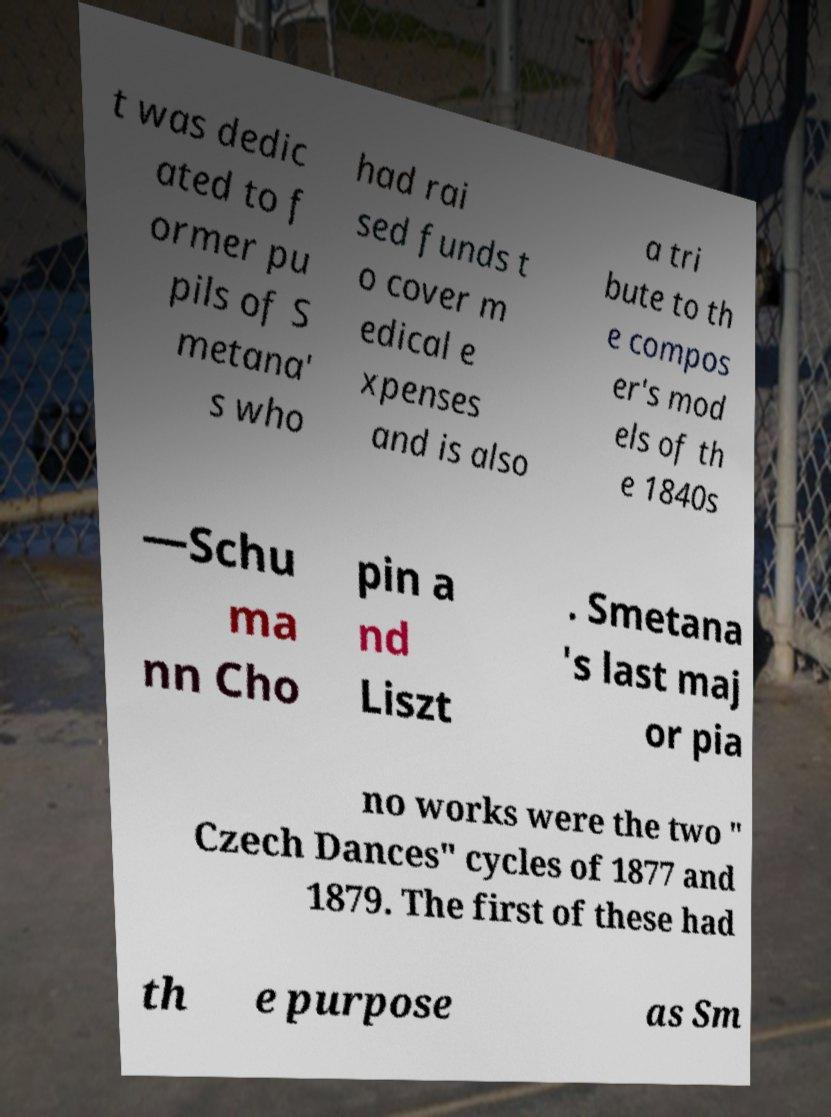Could you assist in decoding the text presented in this image and type it out clearly? t was dedic ated to f ormer pu pils of S metana' s who had rai sed funds t o cover m edical e xpenses and is also a tri bute to th e compos er's mod els of th e 1840s —Schu ma nn Cho pin a nd Liszt . Smetana 's last maj or pia no works were the two " Czech Dances" cycles of 1877 and 1879. The first of these had th e purpose as Sm 